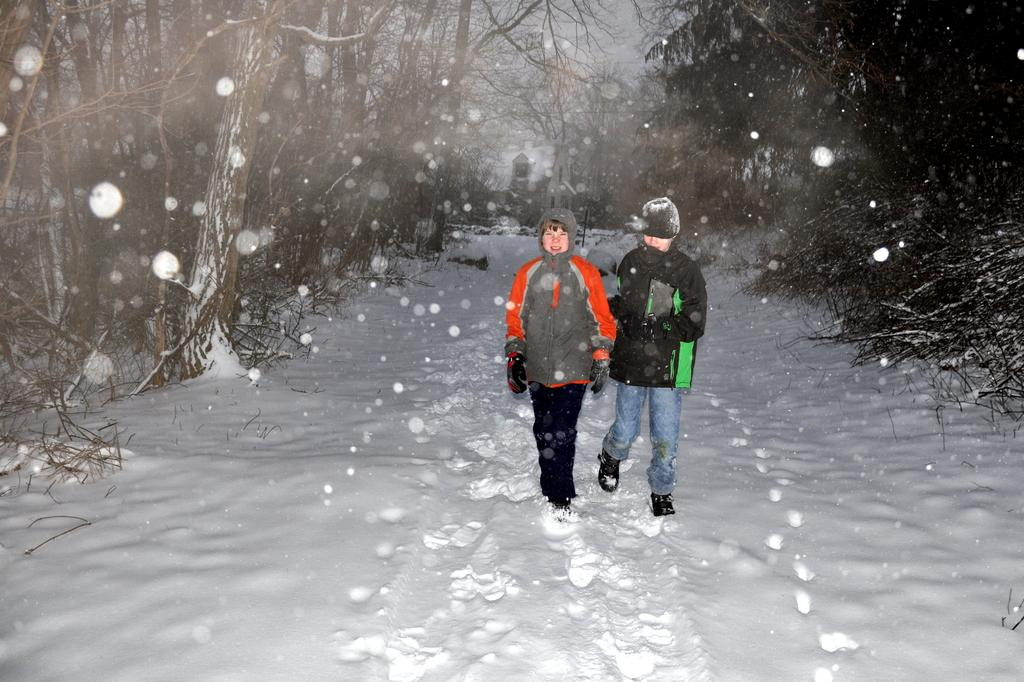How many people are in the image? There are two persons in the image. What are the persons doing in the image? The persons are walking on the snow. What can be seen in the background of the image? There are trees and a house in the background of the image. What is happening in the sky in the image? Snow is falling in the background of the image. How many cats are visible in the image? There are no cats present in the image. What attraction is the image promoting? The image is not promoting any attraction; it simply shows two people walking on snow with a background of trees and a house. 